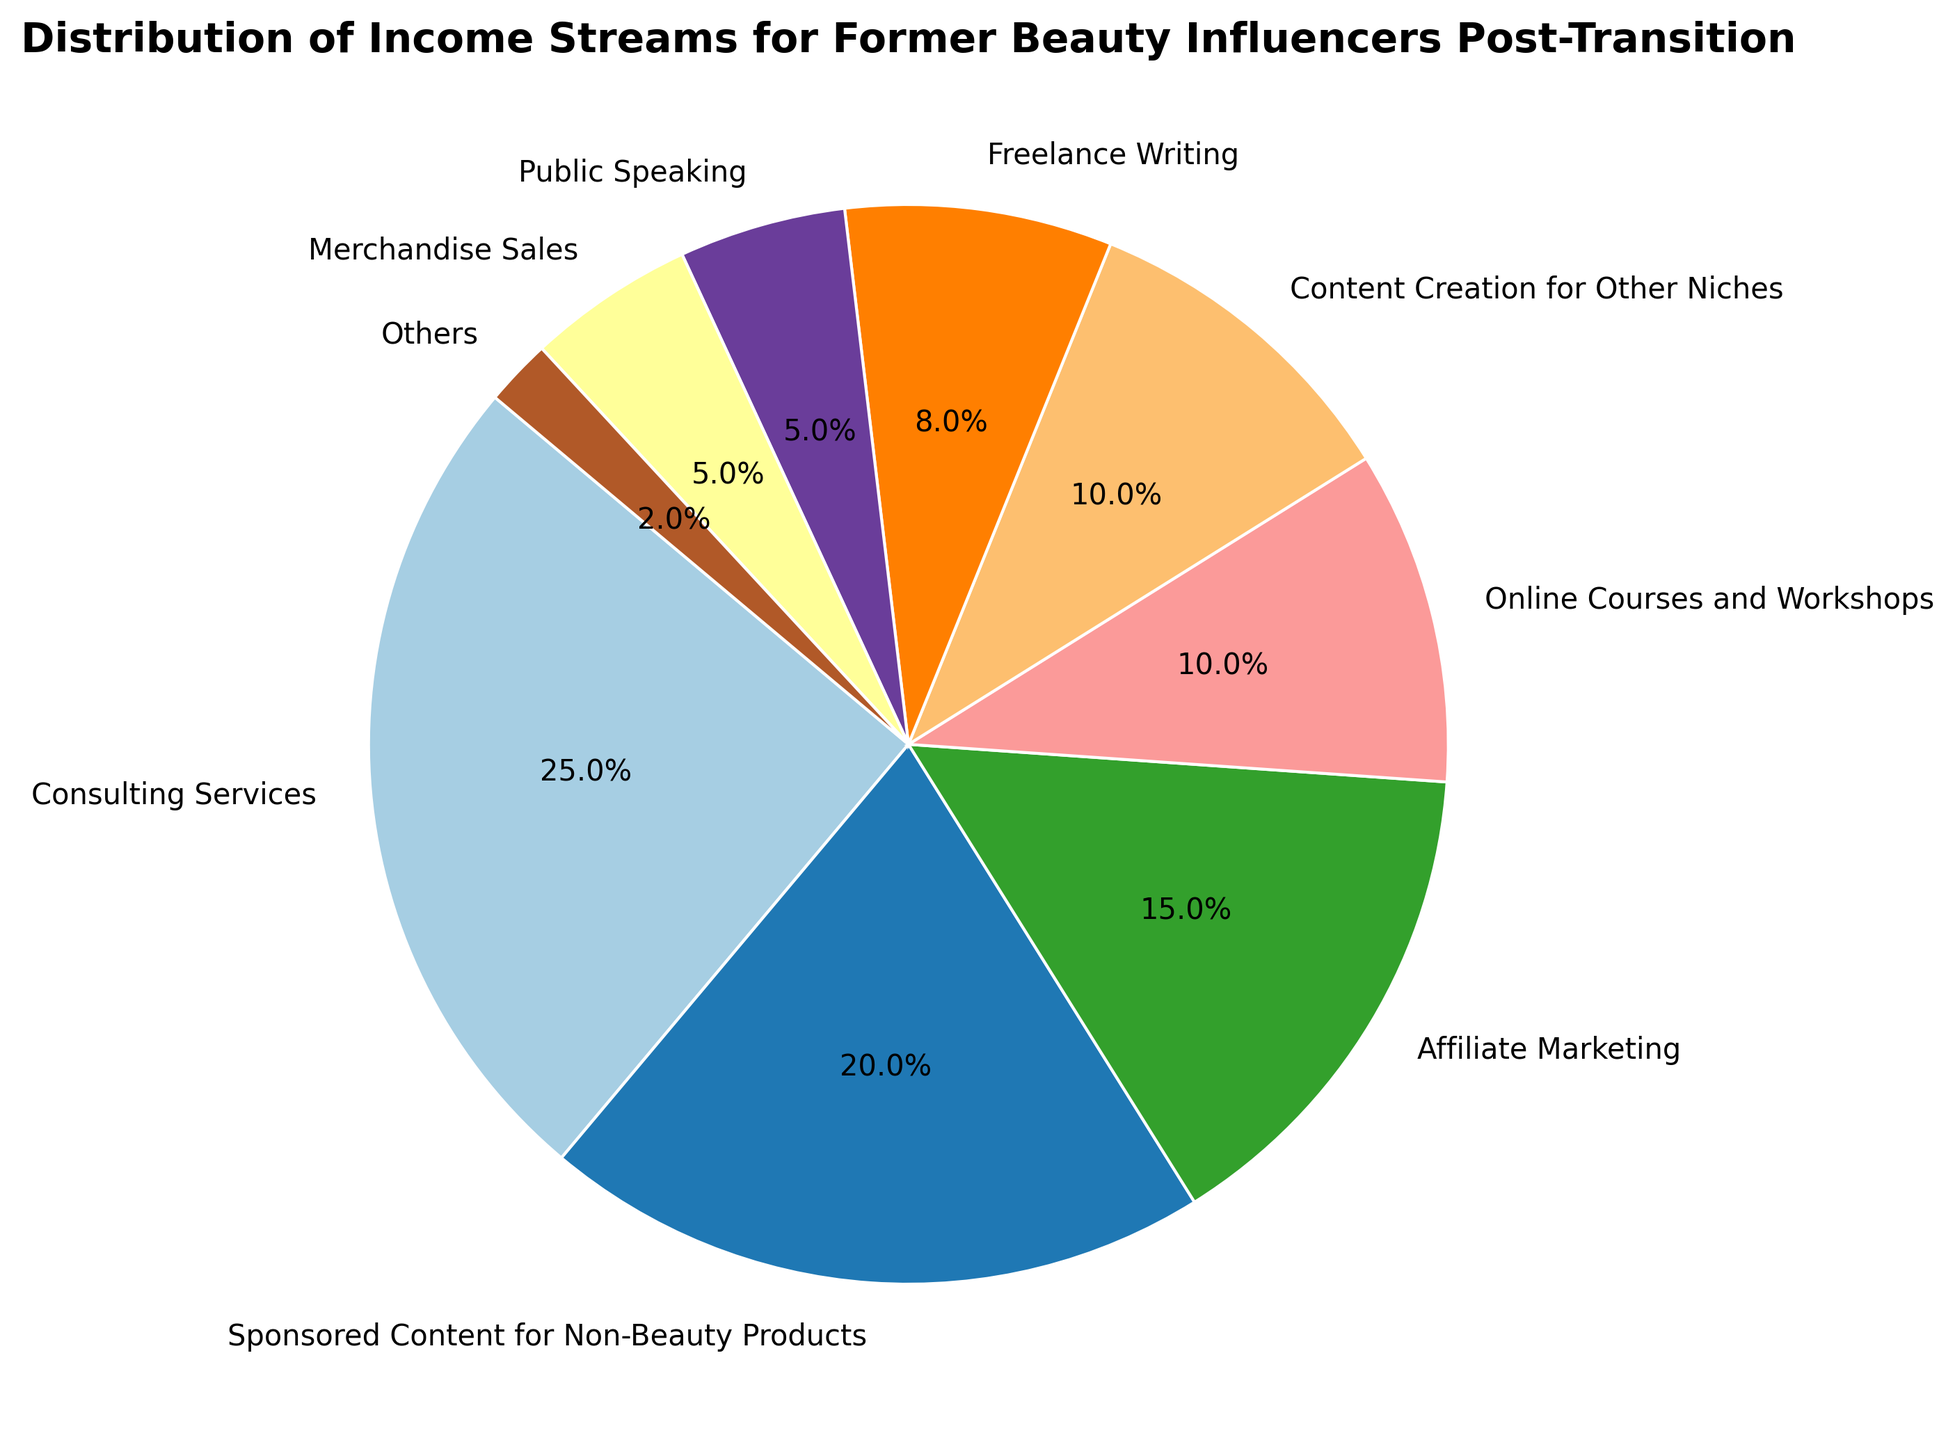Which income stream holds the largest percentage? The pie chart shows different income streams with their respective percentages, and the largest wedge represents 'Consulting Services' at 25%.
Answer: Consulting Services How much more percentage does 'Consulting Services' have compared to 'Public Speaking'? 'Consulting Services' has 25%, and 'Public Speaking' has 5%. The difference is 25% - 5% = 20%.
Answer: 20% What is the combined percentage of 'Online Courses and Workshops' and 'Content Creation for Other Niches'? The percentage for 'Online Courses and Workshops' is 10%, and for 'Content Creation for Other Niches' is also 10%. Their combined percentage is 10% + 10% = 20%.
Answer: 20% Is 'Affiliate Marketing' contributing more to the income streams than 'Freelance Writing'? 'Affiliate Marketing' contributes 15%, whereas 'Freelance Writing' contributes 8%. Hence, 'Affiliate Marketing' contributes more.
Answer: Yes Which income stream has the smallest percentage? According to the pie chart, 'Others' has the smallest percentage which is 2%.
Answer: Others How many income streams have a percentage that is 10% or more? The slices labeled 'Consulting Services', 'Sponsored Content for Non-Beauty Products', 'Affiliate Marketing', 'Online Courses and Workshops', and 'Content Creation for Other Niches' each have 10% or more. Hence, there are five streams.
Answer: 5 What is the total percentage of the income streams that account for less than 10% each? Adding up the percentages of these streams ('Freelance Writing': 8%, 'Public Speaking': 5%, 'Merchandise Sales': 5%, 'Others': 2%) = 8% + 5% + 5% + 2% = 20%.
Answer: 20% Compare the combined percentages of 'Consulting Services' and 'Sponsored Content for Non-Beauty Products' to that of all other streams combined. 'Consulting Services' and 'Sponsored Content for Non-Beauty Products' combined: 25% + 20% = 45%. All other streams combined: 15% (Affiliate Marketing) + 10% (Online Courses and Workshops) + 10% (Content Creation for Other Niches) + 8% (Freelance Writing) + 5% (Public Speaking) + 5% (Merchandise Sales) + 2% (Others) = 55%.
Answer: 45% vs 55% How does the percentage of 'Sponsored Content for Non-Beauty Products' compare to the total percentage of 'Freelance Writing' and 'Merchandise Sales' combined? 'Sponsored Content for Non-Beauty Products' is 20%, while 'Freelance Writing' and 'Merchandise Sales' combined: 8% + 5% = 13%.
Answer: 20% vs 13% Which income stream occupies the largest section of the chart in terms of visual area? The pie chart's largest area is taken by the 'Consulting Services' wedge.
Answer: Consulting Services 